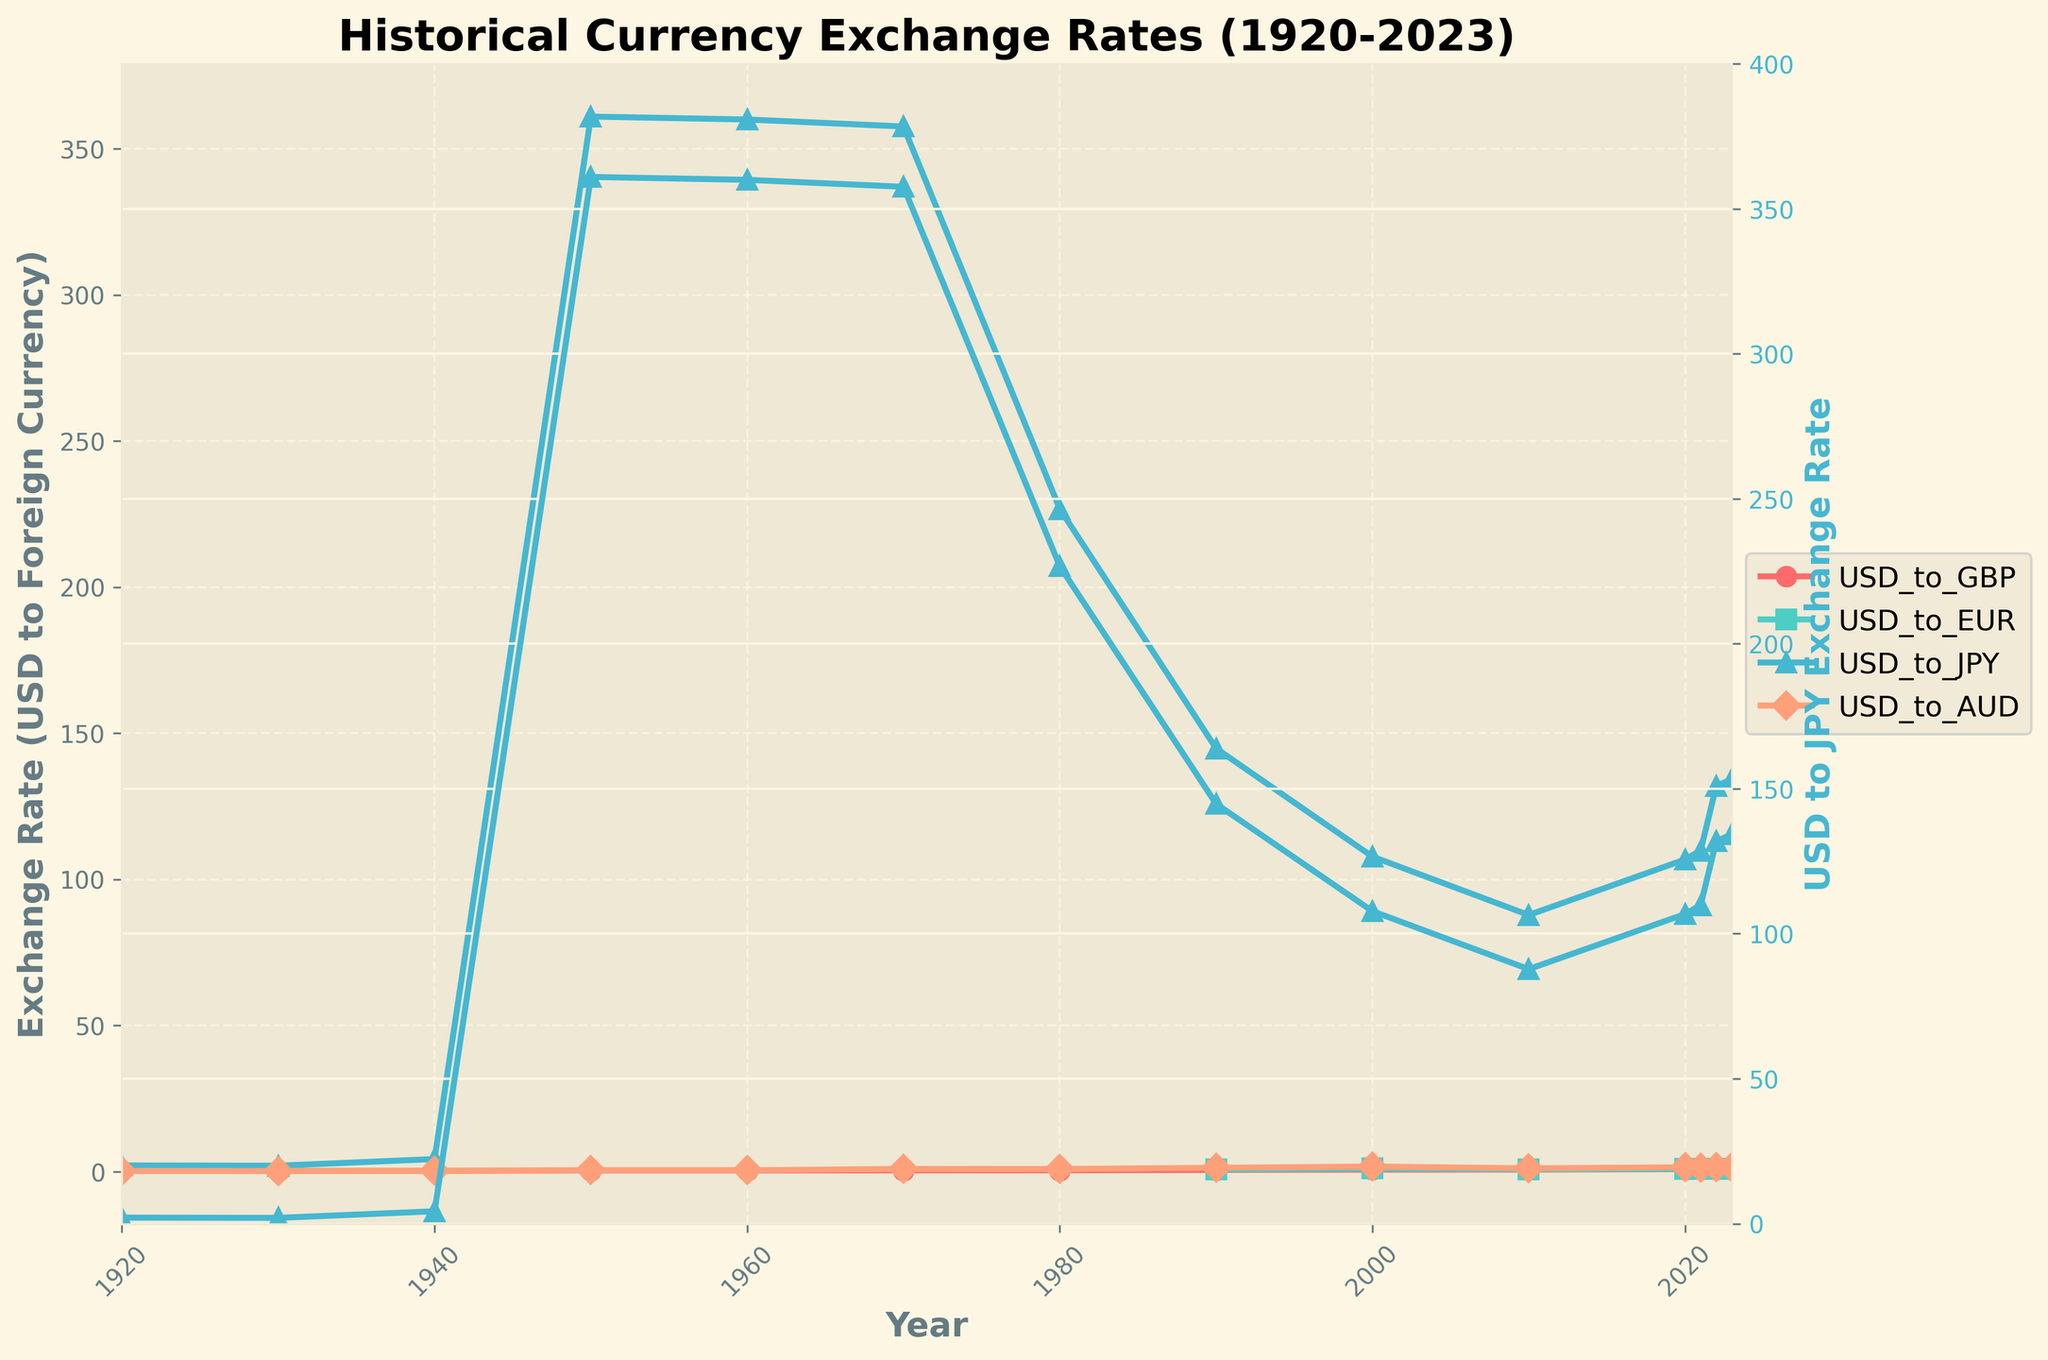How has the USD to GBP exchange rate changed from 1920 to 2023? First, locate the points for USD to GBP on the chart for the years 1920 and 2023. In 1920, the exchange rate was approximately 0.2532. In 2023, the rate has increased to about 0.8038. The change is found by calculating the difference between the two values: 0.8038 - 0.2532 = 0.5506.
Answer: Increased by 0.5506 Comparing the USD to JPY exchange rate, which decade had the most significant decrease? Identify the points for USD to JPY for each decade. The biggest decrease seems to happen from 1980 to 1990, where the rate dropped from around 226.74 to 144.79 (226.74 - 144.79 = 81.95). Check other decades, but this has the largest decrease.
Answer: 1980 to 1990 Which currency experienced the most stability from 1950 to 1970? Observe the line plot for each currency between 1950 and 1970. The USD to GBP line remains flat at approximately 0.3571, indicating it experienced the most stability during this period. All other currencies have more fluctuations.
Answer: USD to GBP What was the average USD to EUR exchange rate in the years it was tracked? Identify the years USD to EUR is available (1990-2023). Sum the values (0.7198 + 1.0854 + 0.7550 + 0.8768 + 0.8450 + 0.9499 + 0.9254 = 6.1573) and then divide by the number of observations (7). 6.1573/7 = 0.8796.
Answer: 0.8796 How does the 2023 USD to AUD exchange rate compare to that in 1950? Find the exchange rates for USD to AUD in 1950 and 2023. In 1950, it’s 0.4464, and in 2023, it’s 1.4845. Compare both values: 1.4845 - 0.4464 = 1.0381. The 2023 rate is higher by this amount.
Answer: 2023 is higher by 1.0381 Which currency had the highest exchange rate fluctuation throughout the century? Observe the range of fluctuations for each currency. USD to JPY fluctuates from 2.0833 in 1920 to 361.0000 in 1950, the highest range among all currencies.
Answer: USD to JPY What was the trend for USD to EUR exchange rate between 2010 and 2023? Find the points for USD to EUR between 2010 and 2023. In 2010, it’s 0.7550, and it gradually increases to 0.9254 by 2023. This indicates a rising trend.
Answer: Increasing trend Which year had the highest USD to GBP exchange rate? Scan the USD to GBP line for the peak value. In 2022, the rate reaches 0.8262, the highest value on the plot.
Answer: 2022 When did the USD to JPY exchange rate see a rapid increase after remaining stable for a long period? Identify stable periods and a subsequent rapid increase on the USD to JPY line. The exchange rate remained stable around 360 from 1950 to 1970, and thereafter saw a rapid increase towards the 1980 mark.
Answer: Around 1970 to 1980 